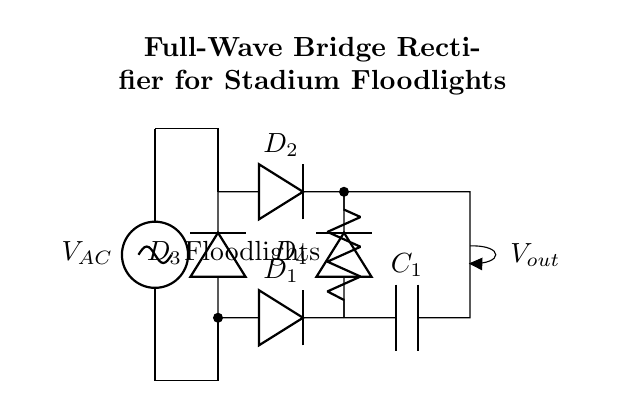What type of rectifier is used in this circuit? The circuit diagram represents a full-wave bridge rectifier, which can be identified by the arrangement of four diodes connected in a bridge configuration.
Answer: full-wave bridge rectifier What are the components of this circuit? The main components visible in the circuit diagram include four diodes, a load labeled as floodlights, and a smoothing capacitor.
Answer: four diodes, floodlights, and a capacitor What is the purpose of the smoothing capacitor? The smoothing capacitor is used to reduce voltage ripples in the output, providing a more stable DC voltage output to the floodlights.
Answer: to reduce voltage ripples How many diodes are conducting when the input AC voltage is positive? In a full-wave bridge rectifier, two diodes conduct during the positive half-cycle of the input AC voltage, allowing current to pass through the load.
Answer: two diodes What happens to the output voltage when the input AC voltage goes negative? When the input AC voltage goes negative, the other two diodes in the bridge rectifier become forward-biased, allowing current to continue flowing through the load, maintaining a constant output voltage.
Answer: it remains positive What is the output voltage labeled as in the circuit diagram? The output voltage is shown in the diagram as just Vout, indicating the voltage available to power the floodlights after rectification.
Answer: Vout 